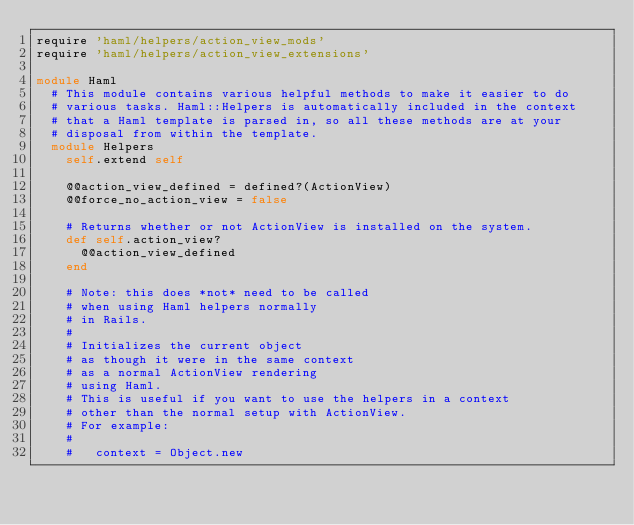<code> <loc_0><loc_0><loc_500><loc_500><_Ruby_>require 'haml/helpers/action_view_mods'
require 'haml/helpers/action_view_extensions'

module Haml
  # This module contains various helpful methods to make it easier to do
  # various tasks. Haml::Helpers is automatically included in the context
  # that a Haml template is parsed in, so all these methods are at your
  # disposal from within the template.
  module Helpers
    self.extend self

    @@action_view_defined = defined?(ActionView)
    @@force_no_action_view = false

    # Returns whether or not ActionView is installed on the system.
    def self.action_view?
      @@action_view_defined
    end

    # Note: this does *not* need to be called
    # when using Haml helpers normally
    # in Rails.
    #
    # Initializes the current object
    # as though it were in the same context
    # as a normal ActionView rendering
    # using Haml.
    # This is useful if you want to use the helpers in a context
    # other than the normal setup with ActionView.
    # For example:
    #
    #   context = Object.new</code> 